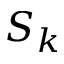Convert formula to latex. <formula><loc_0><loc_0><loc_500><loc_500>S _ { k }</formula> 